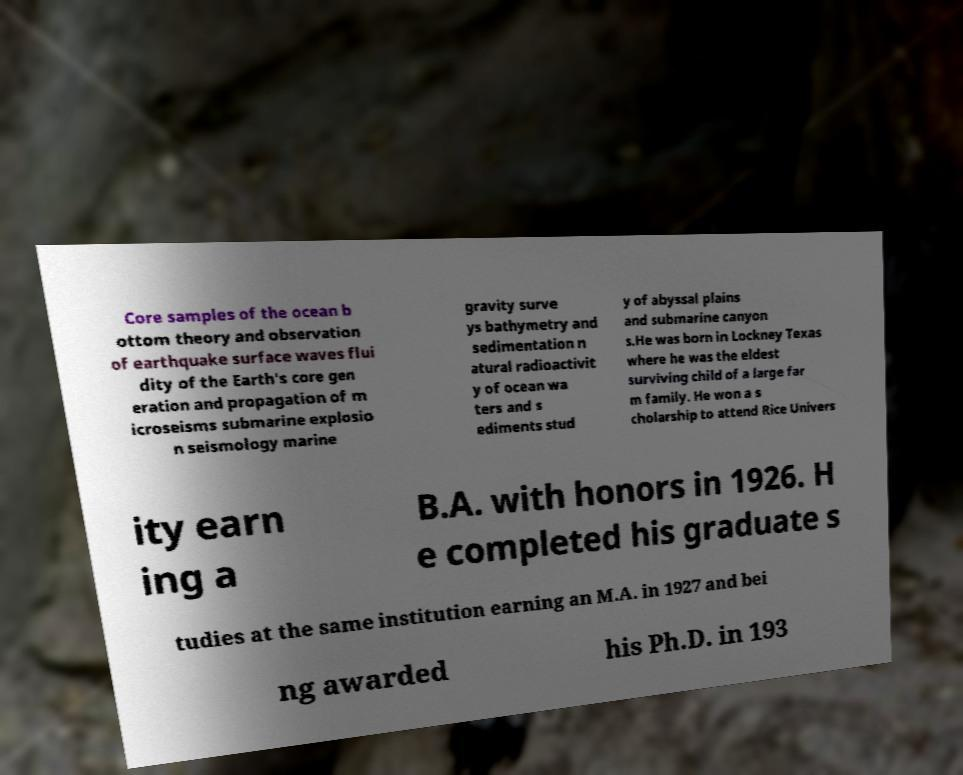For documentation purposes, I need the text within this image transcribed. Could you provide that? Core samples of the ocean b ottom theory and observation of earthquake surface waves flui dity of the Earth's core gen eration and propagation of m icroseisms submarine explosio n seismology marine gravity surve ys bathymetry and sedimentation n atural radioactivit y of ocean wa ters and s ediments stud y of abyssal plains and submarine canyon s.He was born in Lockney Texas where he was the eldest surviving child of a large far m family. He won a s cholarship to attend Rice Univers ity earn ing a B.A. with honors in 1926. H e completed his graduate s tudies at the same institution earning an M.A. in 1927 and bei ng awarded his Ph.D. in 193 